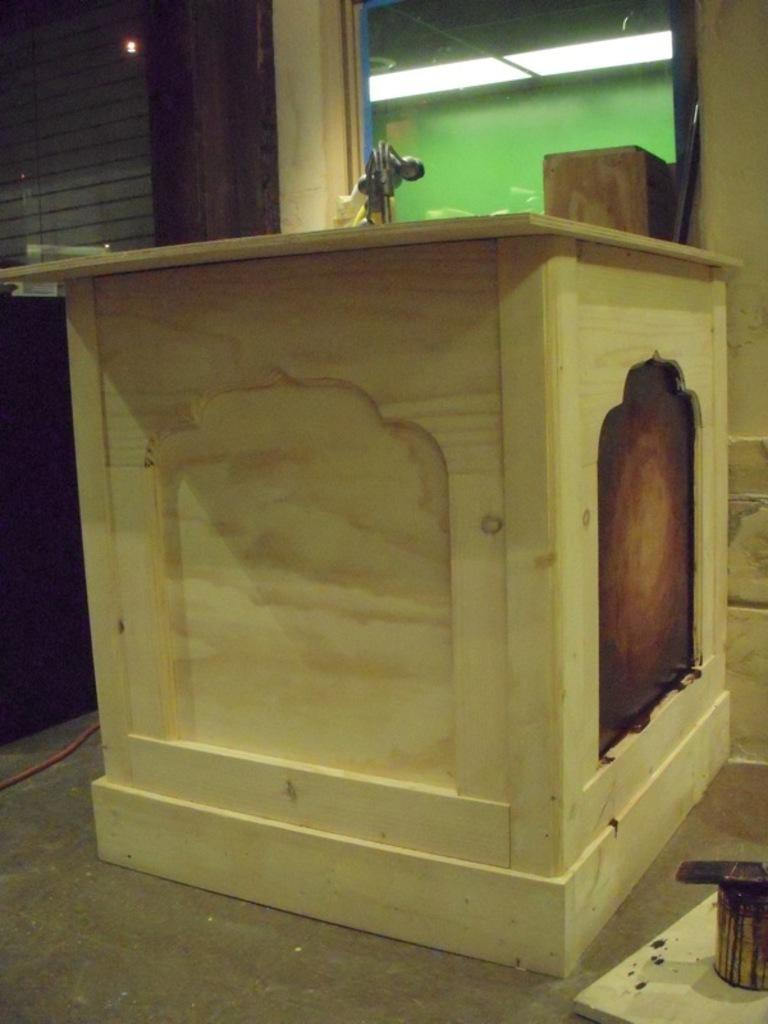What object can be seen in the image that might be used for storage? There is a box in the image that might be used for storage. What object can be seen in the image that might be used for painting? There is a paint bucket in the image that might be used for painting. What object can be seen in the image that might be used for applying paint? There is a brush in the image that might be used for applying paint. Where are the paint bucket and brush located in the image? The paint bucket and brush are located in the bottom right of the image. What type of experience does the box have in the image? The box is an inanimate object and does not have experiences. Does the existence of the paint bucket and brush in the image suggest that the person who took the image is a painter? The presence of the paint bucket and brush in the image does not definitively suggest that the person who took the image is a painter, as these objects could be present for various reasons. 